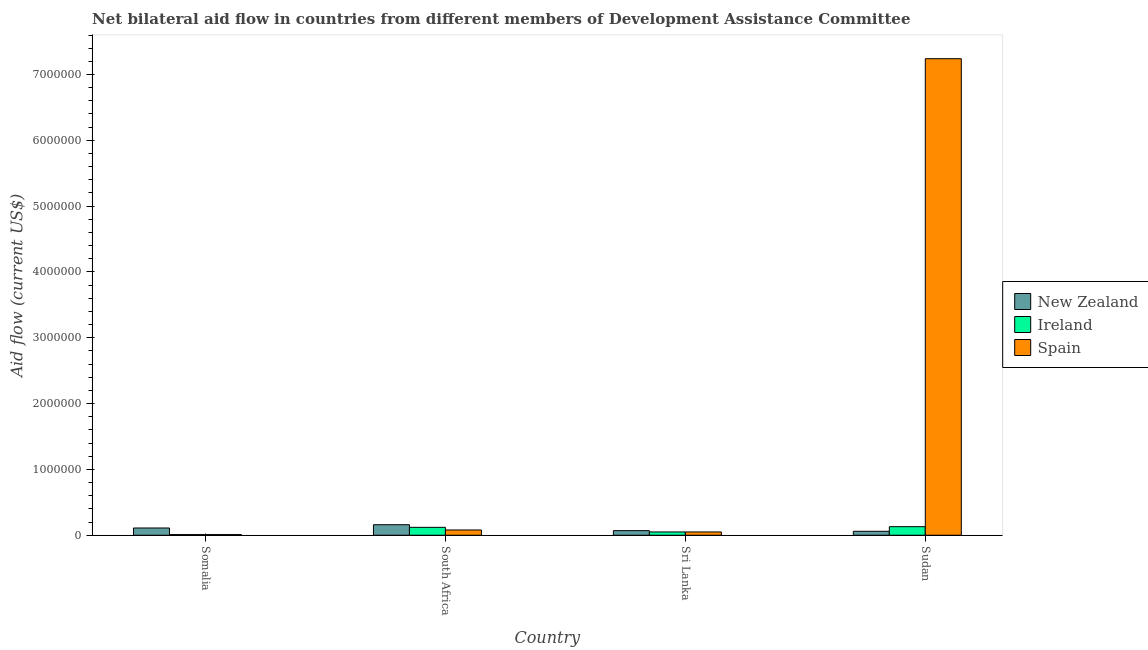How many groups of bars are there?
Provide a short and direct response. 4. How many bars are there on the 1st tick from the left?
Make the answer very short. 3. What is the label of the 4th group of bars from the left?
Give a very brief answer. Sudan. What is the amount of aid provided by new zealand in Sudan?
Give a very brief answer. 6.00e+04. Across all countries, what is the maximum amount of aid provided by ireland?
Offer a terse response. 1.30e+05. Across all countries, what is the minimum amount of aid provided by spain?
Your answer should be compact. 10000. In which country was the amount of aid provided by ireland maximum?
Your answer should be compact. Sudan. In which country was the amount of aid provided by spain minimum?
Make the answer very short. Somalia. What is the total amount of aid provided by ireland in the graph?
Ensure brevity in your answer.  3.10e+05. What is the difference between the amount of aid provided by new zealand in South Africa and that in Sudan?
Your response must be concise. 1.00e+05. What is the difference between the amount of aid provided by spain in Somalia and the amount of aid provided by ireland in South Africa?
Offer a terse response. -1.10e+05. What is the average amount of aid provided by ireland per country?
Ensure brevity in your answer.  7.75e+04. What is the difference between the amount of aid provided by spain and amount of aid provided by ireland in Sudan?
Provide a short and direct response. 7.11e+06. In how many countries, is the amount of aid provided by spain greater than 6400000 US$?
Provide a short and direct response. 1. Is the amount of aid provided by spain in Somalia less than that in Sudan?
Provide a succinct answer. Yes. What is the difference between the highest and the second highest amount of aid provided by spain?
Provide a short and direct response. 7.16e+06. What is the difference between the highest and the lowest amount of aid provided by ireland?
Offer a terse response. 1.20e+05. In how many countries, is the amount of aid provided by spain greater than the average amount of aid provided by spain taken over all countries?
Your response must be concise. 1. Is the sum of the amount of aid provided by spain in Sri Lanka and Sudan greater than the maximum amount of aid provided by ireland across all countries?
Keep it short and to the point. Yes. What does the 1st bar from the left in Sri Lanka represents?
Offer a very short reply. New Zealand. What does the 2nd bar from the right in Sudan represents?
Your answer should be compact. Ireland. How many bars are there?
Your response must be concise. 12. Are all the bars in the graph horizontal?
Offer a terse response. No. Are the values on the major ticks of Y-axis written in scientific E-notation?
Offer a terse response. No. Where does the legend appear in the graph?
Provide a succinct answer. Center right. What is the title of the graph?
Your response must be concise. Net bilateral aid flow in countries from different members of Development Assistance Committee. What is the label or title of the Y-axis?
Ensure brevity in your answer.  Aid flow (current US$). What is the Aid flow (current US$) of Spain in Somalia?
Your answer should be compact. 10000. What is the Aid flow (current US$) of Ireland in South Africa?
Ensure brevity in your answer.  1.20e+05. What is the Aid flow (current US$) of Spain in South Africa?
Your response must be concise. 8.00e+04. What is the Aid flow (current US$) of New Zealand in Sri Lanka?
Ensure brevity in your answer.  7.00e+04. What is the Aid flow (current US$) in Ireland in Sri Lanka?
Your answer should be very brief. 5.00e+04. What is the Aid flow (current US$) of Spain in Sri Lanka?
Ensure brevity in your answer.  5.00e+04. What is the Aid flow (current US$) in New Zealand in Sudan?
Ensure brevity in your answer.  6.00e+04. What is the Aid flow (current US$) in Spain in Sudan?
Make the answer very short. 7.24e+06. Across all countries, what is the maximum Aid flow (current US$) in New Zealand?
Make the answer very short. 1.60e+05. Across all countries, what is the maximum Aid flow (current US$) in Spain?
Your answer should be very brief. 7.24e+06. Across all countries, what is the minimum Aid flow (current US$) of Ireland?
Provide a succinct answer. 10000. Across all countries, what is the minimum Aid flow (current US$) of Spain?
Your answer should be very brief. 10000. What is the total Aid flow (current US$) in Ireland in the graph?
Make the answer very short. 3.10e+05. What is the total Aid flow (current US$) of Spain in the graph?
Make the answer very short. 7.38e+06. What is the difference between the Aid flow (current US$) of Ireland in Somalia and that in South Africa?
Give a very brief answer. -1.10e+05. What is the difference between the Aid flow (current US$) of Spain in Somalia and that in South Africa?
Give a very brief answer. -7.00e+04. What is the difference between the Aid flow (current US$) in New Zealand in Somalia and that in Sudan?
Your answer should be compact. 5.00e+04. What is the difference between the Aid flow (current US$) in Spain in Somalia and that in Sudan?
Provide a short and direct response. -7.23e+06. What is the difference between the Aid flow (current US$) in Ireland in South Africa and that in Sri Lanka?
Provide a succinct answer. 7.00e+04. What is the difference between the Aid flow (current US$) of Ireland in South Africa and that in Sudan?
Ensure brevity in your answer.  -10000. What is the difference between the Aid flow (current US$) of Spain in South Africa and that in Sudan?
Your answer should be compact. -7.16e+06. What is the difference between the Aid flow (current US$) of New Zealand in Sri Lanka and that in Sudan?
Provide a short and direct response. 10000. What is the difference between the Aid flow (current US$) in Ireland in Sri Lanka and that in Sudan?
Your answer should be compact. -8.00e+04. What is the difference between the Aid flow (current US$) of Spain in Sri Lanka and that in Sudan?
Ensure brevity in your answer.  -7.19e+06. What is the difference between the Aid flow (current US$) of New Zealand in Somalia and the Aid flow (current US$) of Spain in South Africa?
Offer a very short reply. 3.00e+04. What is the difference between the Aid flow (current US$) of Ireland in Somalia and the Aid flow (current US$) of Spain in South Africa?
Make the answer very short. -7.00e+04. What is the difference between the Aid flow (current US$) of New Zealand in Somalia and the Aid flow (current US$) of Spain in Sri Lanka?
Ensure brevity in your answer.  6.00e+04. What is the difference between the Aid flow (current US$) of Ireland in Somalia and the Aid flow (current US$) of Spain in Sri Lanka?
Make the answer very short. -4.00e+04. What is the difference between the Aid flow (current US$) in New Zealand in Somalia and the Aid flow (current US$) in Ireland in Sudan?
Ensure brevity in your answer.  -2.00e+04. What is the difference between the Aid flow (current US$) in New Zealand in Somalia and the Aid flow (current US$) in Spain in Sudan?
Offer a terse response. -7.13e+06. What is the difference between the Aid flow (current US$) of Ireland in Somalia and the Aid flow (current US$) of Spain in Sudan?
Provide a succinct answer. -7.23e+06. What is the difference between the Aid flow (current US$) of Ireland in South Africa and the Aid flow (current US$) of Spain in Sri Lanka?
Your response must be concise. 7.00e+04. What is the difference between the Aid flow (current US$) in New Zealand in South Africa and the Aid flow (current US$) in Ireland in Sudan?
Your answer should be compact. 3.00e+04. What is the difference between the Aid flow (current US$) of New Zealand in South Africa and the Aid flow (current US$) of Spain in Sudan?
Offer a very short reply. -7.08e+06. What is the difference between the Aid flow (current US$) in Ireland in South Africa and the Aid flow (current US$) in Spain in Sudan?
Provide a short and direct response. -7.12e+06. What is the difference between the Aid flow (current US$) of New Zealand in Sri Lanka and the Aid flow (current US$) of Spain in Sudan?
Make the answer very short. -7.17e+06. What is the difference between the Aid flow (current US$) in Ireland in Sri Lanka and the Aid flow (current US$) in Spain in Sudan?
Keep it short and to the point. -7.19e+06. What is the average Aid flow (current US$) in New Zealand per country?
Keep it short and to the point. 1.00e+05. What is the average Aid flow (current US$) in Ireland per country?
Offer a terse response. 7.75e+04. What is the average Aid flow (current US$) in Spain per country?
Ensure brevity in your answer.  1.84e+06. What is the difference between the Aid flow (current US$) in Ireland and Aid flow (current US$) in Spain in Somalia?
Your answer should be very brief. 0. What is the difference between the Aid flow (current US$) of New Zealand and Aid flow (current US$) of Ireland in South Africa?
Provide a succinct answer. 4.00e+04. What is the difference between the Aid flow (current US$) of New Zealand and Aid flow (current US$) of Ireland in Sri Lanka?
Your answer should be compact. 2.00e+04. What is the difference between the Aid flow (current US$) in New Zealand and Aid flow (current US$) in Spain in Sudan?
Your answer should be very brief. -7.18e+06. What is the difference between the Aid flow (current US$) of Ireland and Aid flow (current US$) of Spain in Sudan?
Ensure brevity in your answer.  -7.11e+06. What is the ratio of the Aid flow (current US$) of New Zealand in Somalia to that in South Africa?
Make the answer very short. 0.69. What is the ratio of the Aid flow (current US$) in Ireland in Somalia to that in South Africa?
Keep it short and to the point. 0.08. What is the ratio of the Aid flow (current US$) of New Zealand in Somalia to that in Sri Lanka?
Offer a terse response. 1.57. What is the ratio of the Aid flow (current US$) in New Zealand in Somalia to that in Sudan?
Keep it short and to the point. 1.83. What is the ratio of the Aid flow (current US$) of Ireland in Somalia to that in Sudan?
Your answer should be compact. 0.08. What is the ratio of the Aid flow (current US$) of Spain in Somalia to that in Sudan?
Your answer should be very brief. 0. What is the ratio of the Aid flow (current US$) in New Zealand in South Africa to that in Sri Lanka?
Provide a short and direct response. 2.29. What is the ratio of the Aid flow (current US$) of New Zealand in South Africa to that in Sudan?
Offer a very short reply. 2.67. What is the ratio of the Aid flow (current US$) in Spain in South Africa to that in Sudan?
Provide a succinct answer. 0.01. What is the ratio of the Aid flow (current US$) of New Zealand in Sri Lanka to that in Sudan?
Keep it short and to the point. 1.17. What is the ratio of the Aid flow (current US$) of Ireland in Sri Lanka to that in Sudan?
Give a very brief answer. 0.38. What is the ratio of the Aid flow (current US$) of Spain in Sri Lanka to that in Sudan?
Give a very brief answer. 0.01. What is the difference between the highest and the second highest Aid flow (current US$) of New Zealand?
Offer a very short reply. 5.00e+04. What is the difference between the highest and the second highest Aid flow (current US$) of Ireland?
Offer a terse response. 10000. What is the difference between the highest and the second highest Aid flow (current US$) of Spain?
Provide a short and direct response. 7.16e+06. What is the difference between the highest and the lowest Aid flow (current US$) in New Zealand?
Make the answer very short. 1.00e+05. What is the difference between the highest and the lowest Aid flow (current US$) in Spain?
Offer a very short reply. 7.23e+06. 